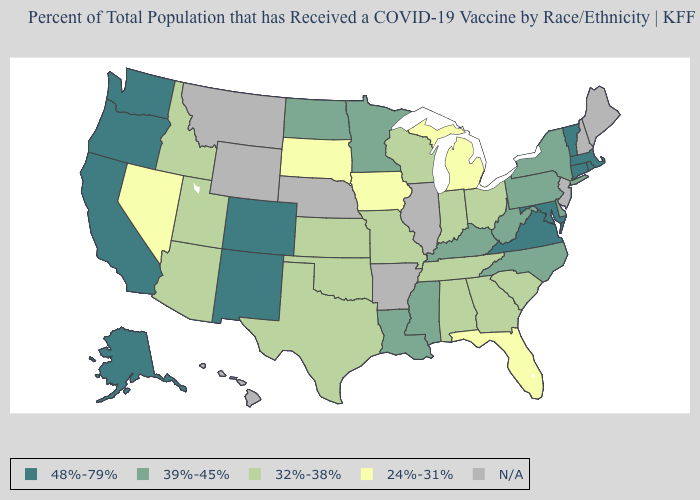What is the value of Florida?
Short answer required. 24%-31%. What is the value of West Virginia?
Keep it brief. 39%-45%. What is the value of New Mexico?
Keep it brief. 48%-79%. Name the states that have a value in the range 39%-45%?
Short answer required. Delaware, Kentucky, Louisiana, Minnesota, Mississippi, New York, North Carolina, North Dakota, Pennsylvania, West Virginia. Name the states that have a value in the range N/A?
Answer briefly. Arkansas, Hawaii, Illinois, Maine, Montana, Nebraska, New Hampshire, New Jersey, Wyoming. Name the states that have a value in the range 24%-31%?
Keep it brief. Florida, Iowa, Michigan, Nevada, South Dakota. What is the lowest value in the West?
Short answer required. 24%-31%. Does Washington have the highest value in the USA?
Short answer required. Yes. Does Nevada have the lowest value in the West?
Be succinct. Yes. Does the map have missing data?
Write a very short answer. Yes. Which states have the lowest value in the USA?
Write a very short answer. Florida, Iowa, Michigan, Nevada, South Dakota. What is the lowest value in the South?
Write a very short answer. 24%-31%. Name the states that have a value in the range 32%-38%?
Short answer required. Alabama, Arizona, Georgia, Idaho, Indiana, Kansas, Missouri, Ohio, Oklahoma, South Carolina, Tennessee, Texas, Utah, Wisconsin. Name the states that have a value in the range 24%-31%?
Give a very brief answer. Florida, Iowa, Michigan, Nevada, South Dakota. 